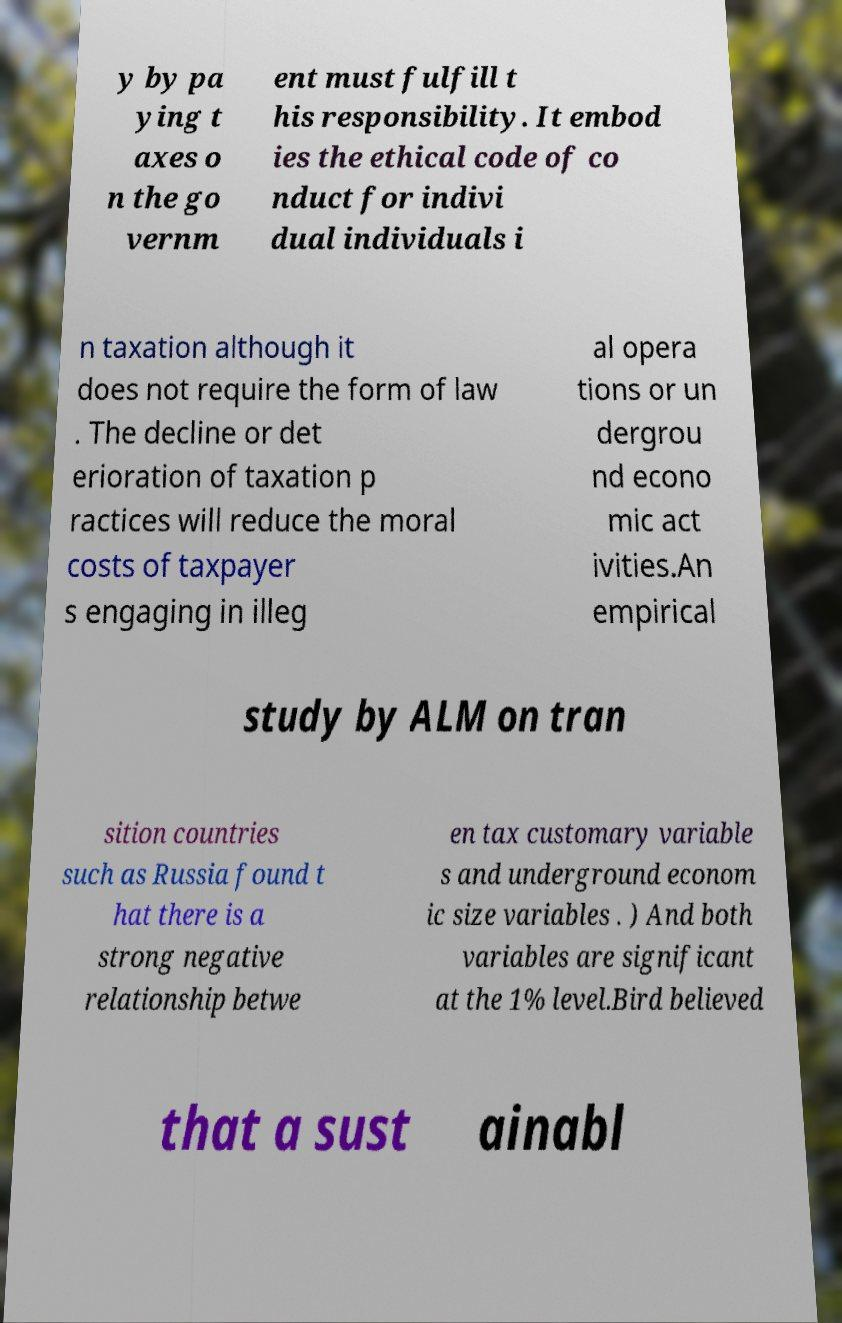Please identify and transcribe the text found in this image. y by pa ying t axes o n the go vernm ent must fulfill t his responsibility. It embod ies the ethical code of co nduct for indivi dual individuals i n taxation although it does not require the form of law . The decline or det erioration of taxation p ractices will reduce the moral costs of taxpayer s engaging in illeg al opera tions or un dergrou nd econo mic act ivities.An empirical study by ALM on tran sition countries such as Russia found t hat there is a strong negative relationship betwe en tax customary variable s and underground econom ic size variables . ) And both variables are significant at the 1% level.Bird believed that a sust ainabl 